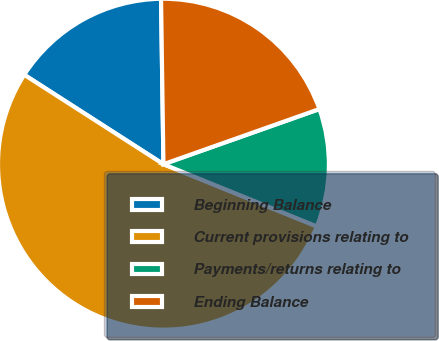Convert chart. <chart><loc_0><loc_0><loc_500><loc_500><pie_chart><fcel>Beginning Balance<fcel>Current provisions relating to<fcel>Payments/returns relating to<fcel>Ending Balance<nl><fcel>15.68%<fcel>52.96%<fcel>11.54%<fcel>19.82%<nl></chart> 